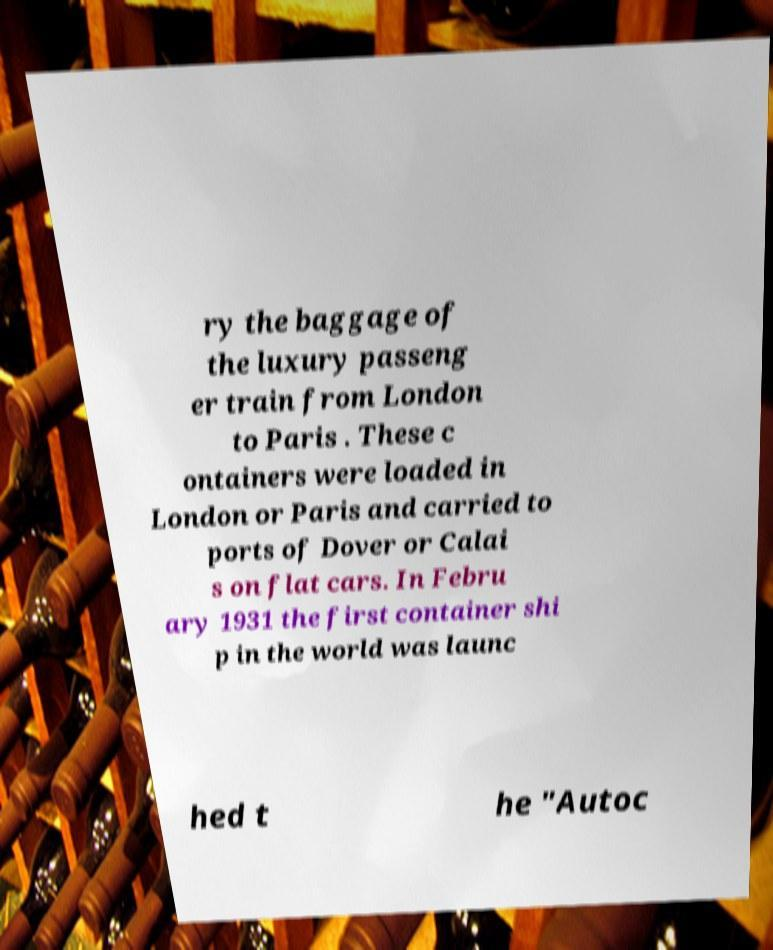Could you assist in decoding the text presented in this image and type it out clearly? ry the baggage of the luxury passeng er train from London to Paris . These c ontainers were loaded in London or Paris and carried to ports of Dover or Calai s on flat cars. In Febru ary 1931 the first container shi p in the world was launc hed t he "Autoc 